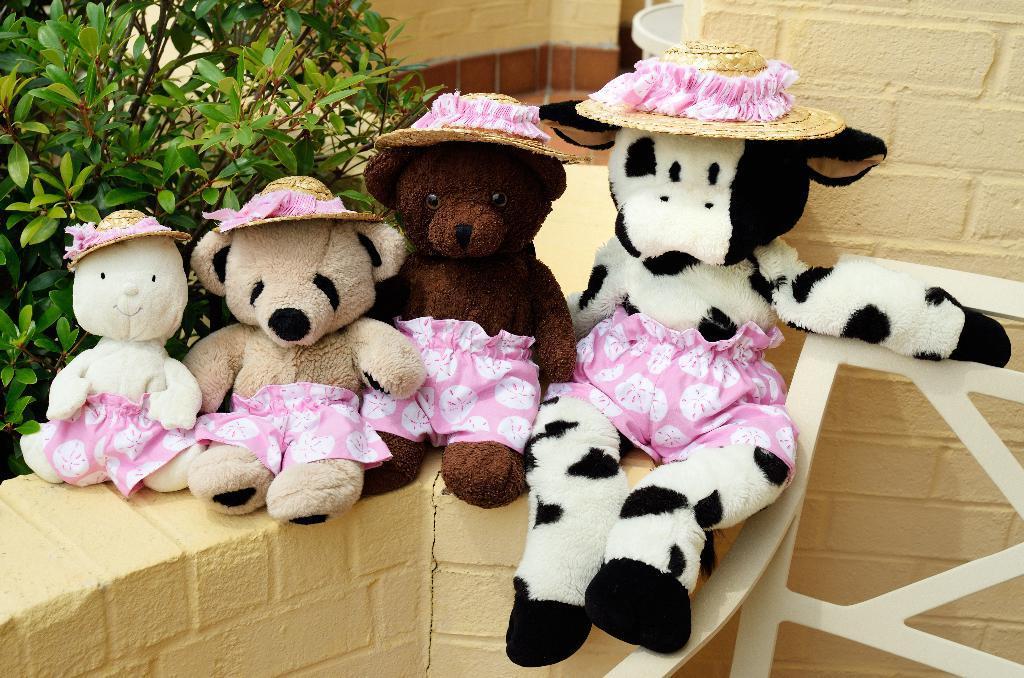In one or two sentences, can you explain what this image depicts? In the image there are teddy bears with hats on the wall, behind it there is a wall. 